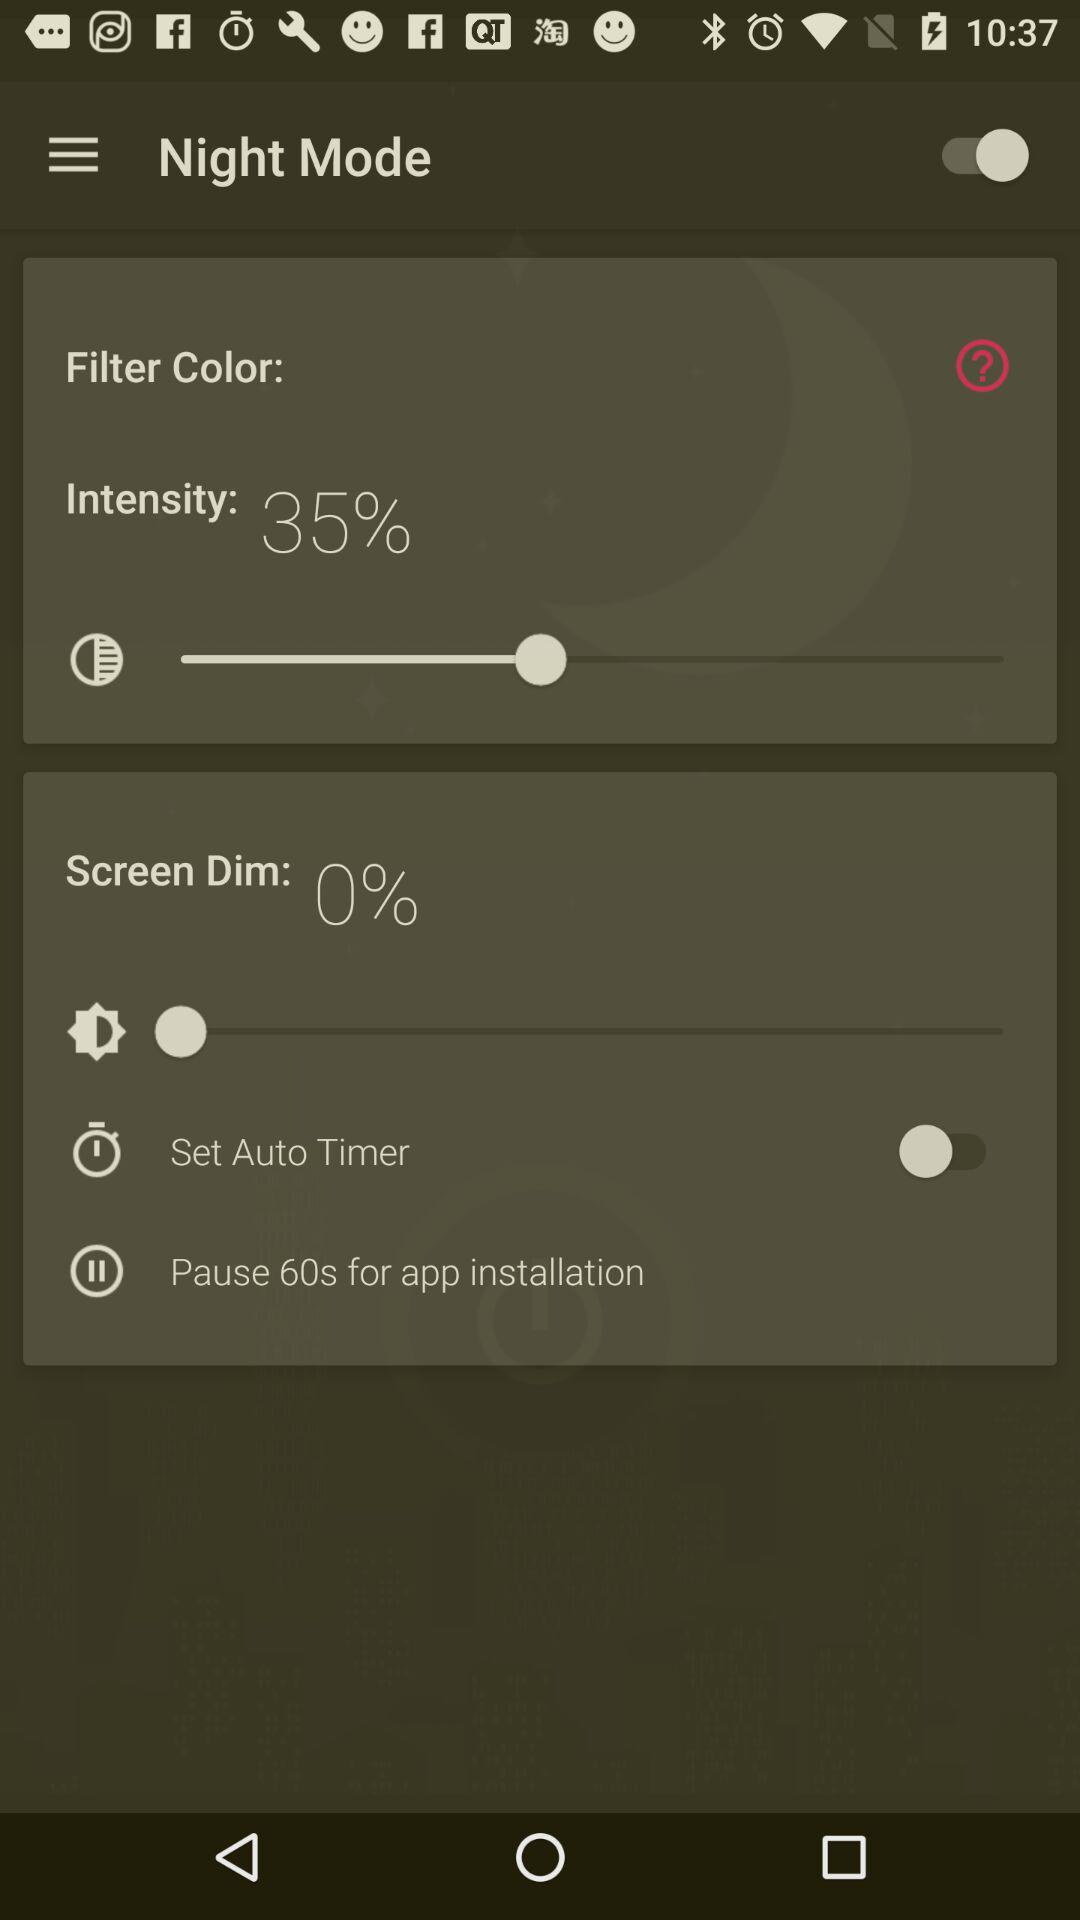How much more dim is the screen than the filter color?
Answer the question using a single word or phrase. 35% 